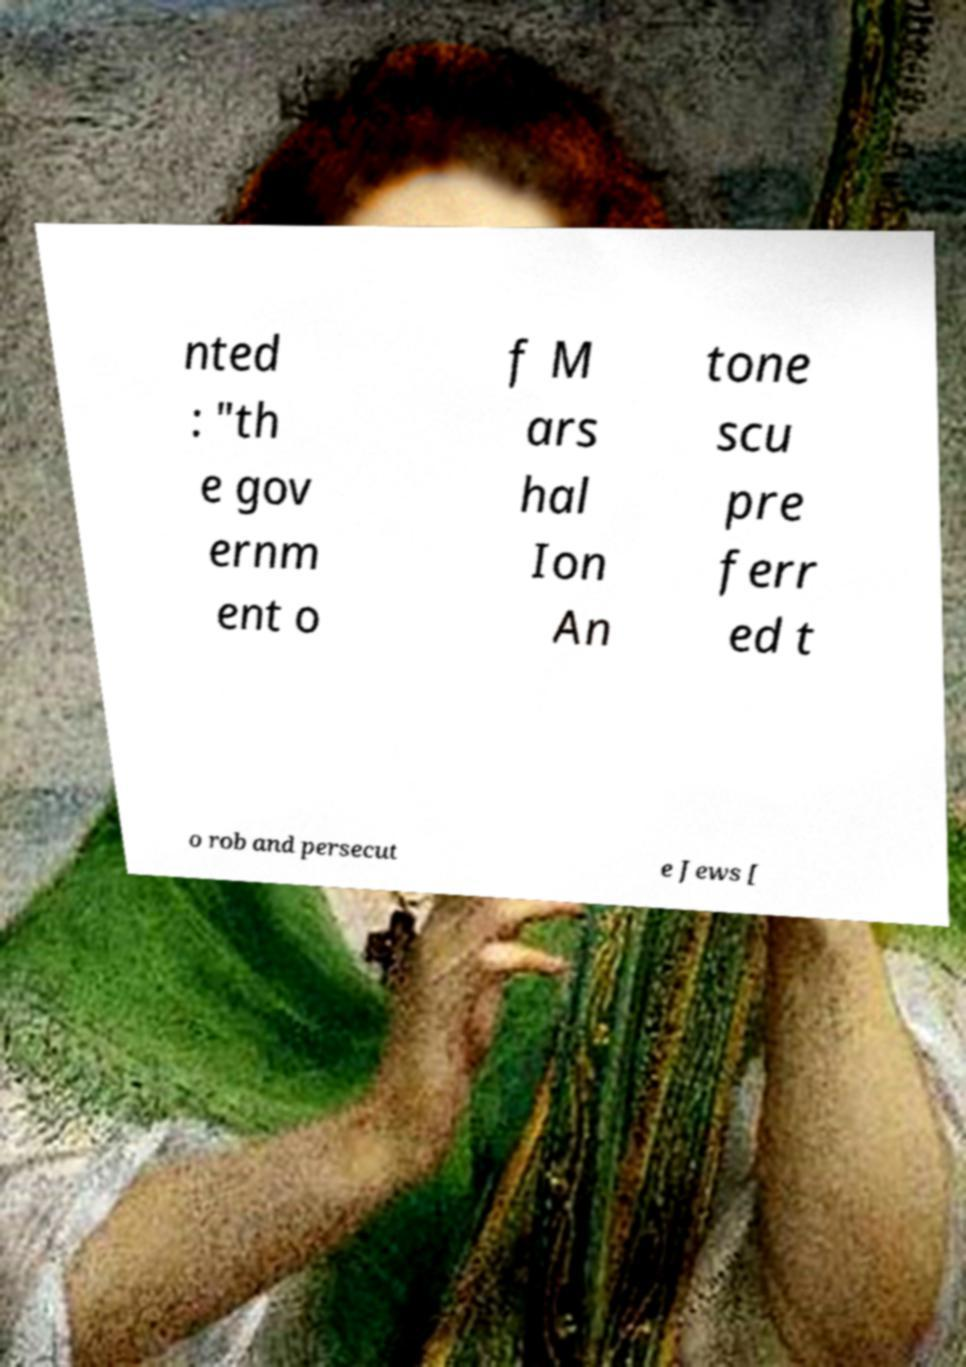Could you extract and type out the text from this image? nted : "th e gov ernm ent o f M ars hal Ion An tone scu pre ferr ed t o rob and persecut e Jews [ 